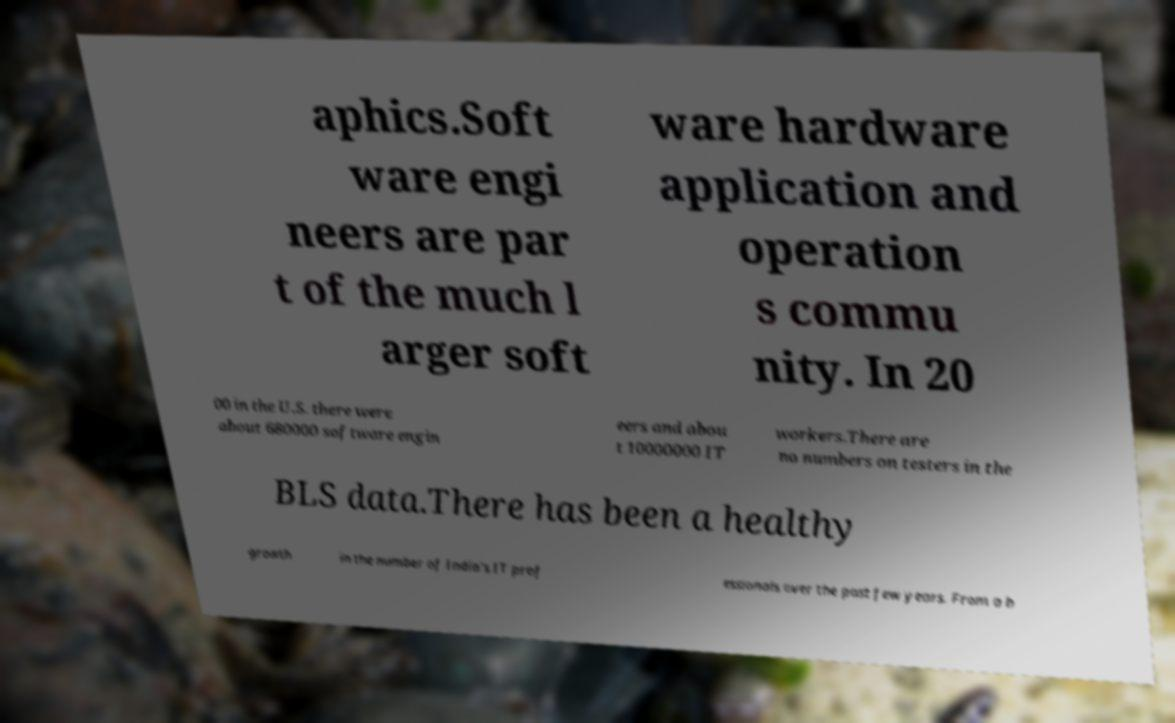Could you assist in decoding the text presented in this image and type it out clearly? aphics.Soft ware engi neers are par t of the much l arger soft ware hardware application and operation s commu nity. In 20 00 in the U.S. there were about 680000 software engin eers and abou t 10000000 IT workers.There are no numbers on testers in the BLS data.There has been a healthy growth in the number of India's IT prof essionals over the past few years. From a b 